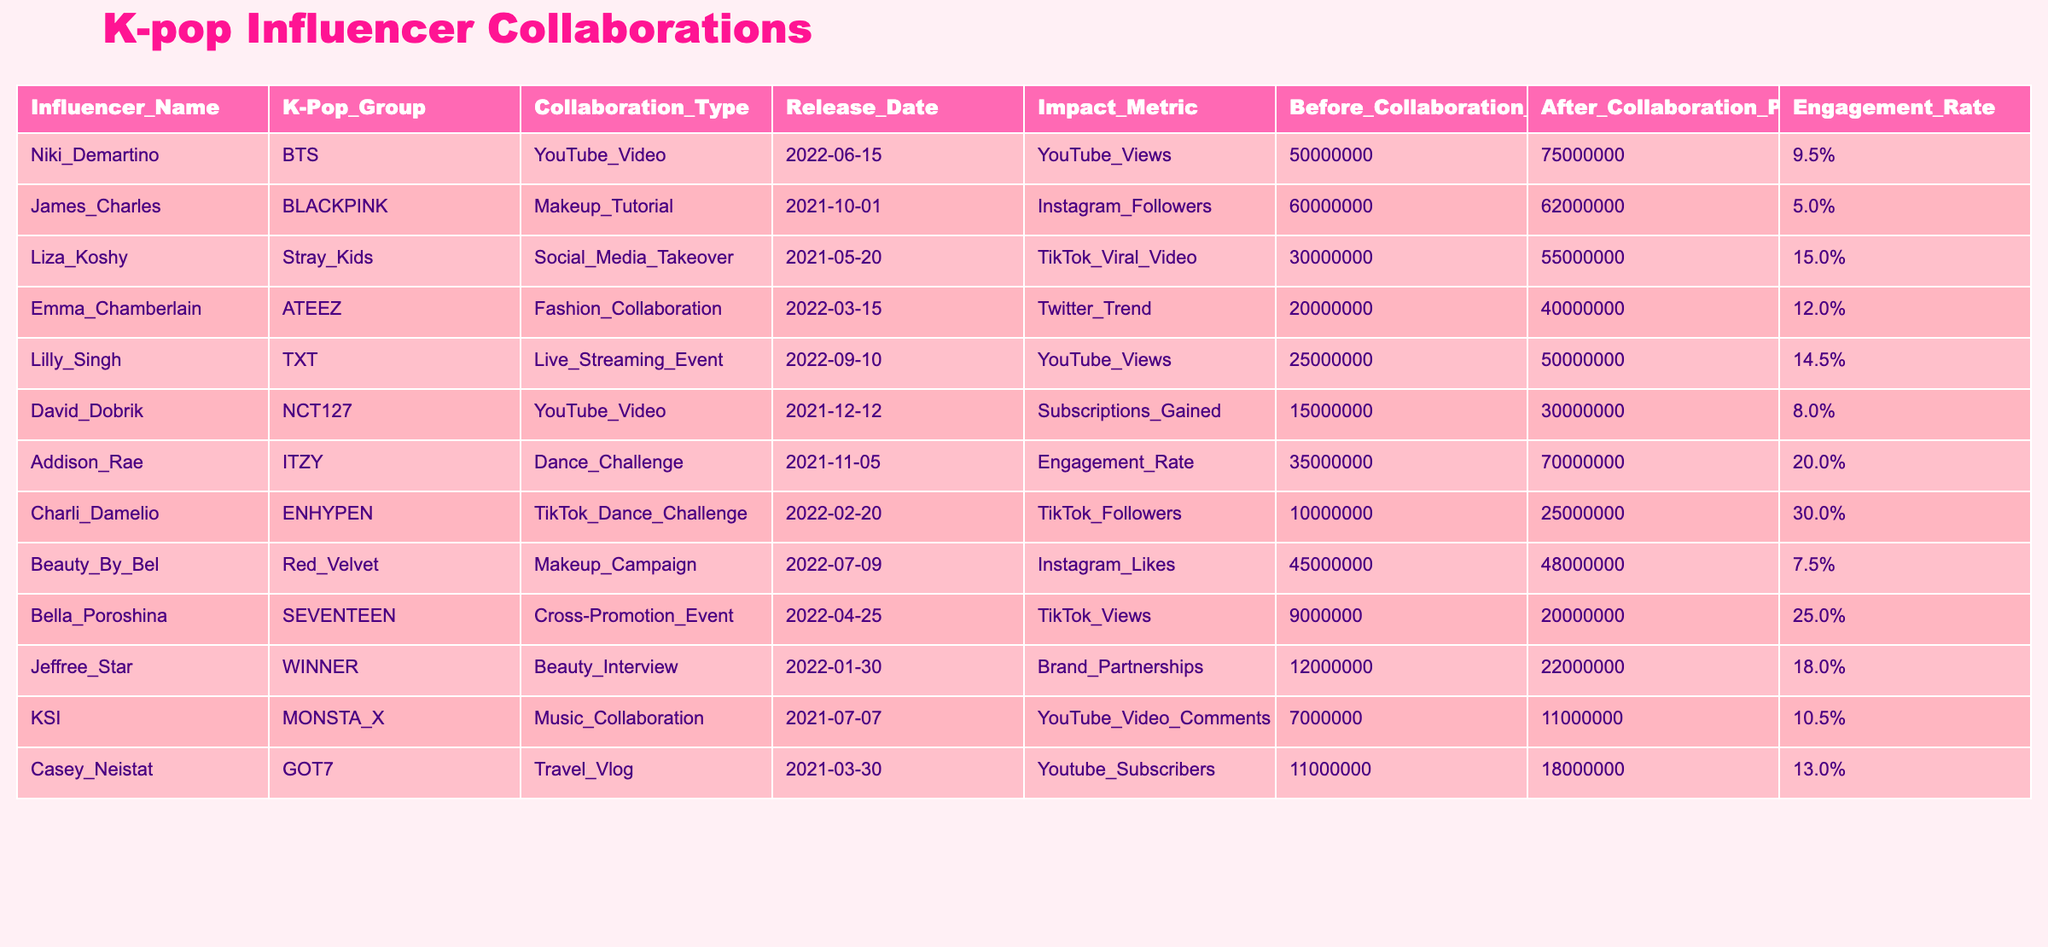What is the highest engagement rate among the collaborations? By examining the "Engagement Rate" column, the highest value is found for the collaboration with Charli D'Amelio and ENHYPEN, which has an engagement rate of 30.0%.
Answer: 30.0% Which K-Pop group had the lowest popularity before collaboration? Looking at the "Before Collaboration Popularity" column, the lowest popularity is for SEVENTEEN, with a before collaboration popularity of 9,000,000.
Answer: 9,000,000 Did Addison Rae’s collaboration with ITZY have a positive impact on their engagement rate? To determine this, we look at the "Before Collaboration Popularity" (35,000,000) and "After Collaboration Popularity" (70,000,000), showing a significant increase in popularity due to engagement rate, which suggests a positive impact.
Answer: Yes What was the average popularity increase for all collaborations? The total increase is calculated by subtracting each "Before Collaboration Popularity" from the respective "After Collaboration Popularity": (75M - 50M) + (62M - 60M) + (55M - 30M) + (40M - 20M) + (50M - 25M) + (30M - 15M) + (70M - 35M) + (25M - 10M) + (48M - 45M) + (22M - 12M) + (11M - 7M) + (18M - 11M) = 133M total increase across 12 collaborations giving an average increase of 11.08M.
Answer: 11.08M Which influencer's collaboration resulted in the highest increase in YouTube Views? By looking at the impact metric "YouTube Views", Niki Demartino's collaboration with BTS had the highest increase, moving from 50,000,000 to 75,000,000, making a difference of 25,000,000 views.
Answer: 25,000,000 Was there a collaboration that resulted in a decrease in YouTube subscribers? Checking the "YouTube Subscribers" impact metric, all the collaborations shown have increased in popularity; therefore, there is no collaboration that resulted in a decrease.
Answer: No How many collaborations focused on social media platforms like TikTok? In the table, there are three collaborations specifically related to TikTok: Stray Kids with Liza Koshy, Charli D'Amelio with ENHYPEN, and Bella Poroshina with SEVENTEEN, totaling three collaborations.
Answer: 3 Which K-Pop group had the most effective collaboration based on the "Impact Metric"? To analyze this, we look at their after popularity shift resulting from the collaborations. The greatest shift was observed with Addison Rae’s collaboration with ITZY, which had an impressive increase of 35,000,000 followers, marking it as the most effective.
Answer: ITZY 